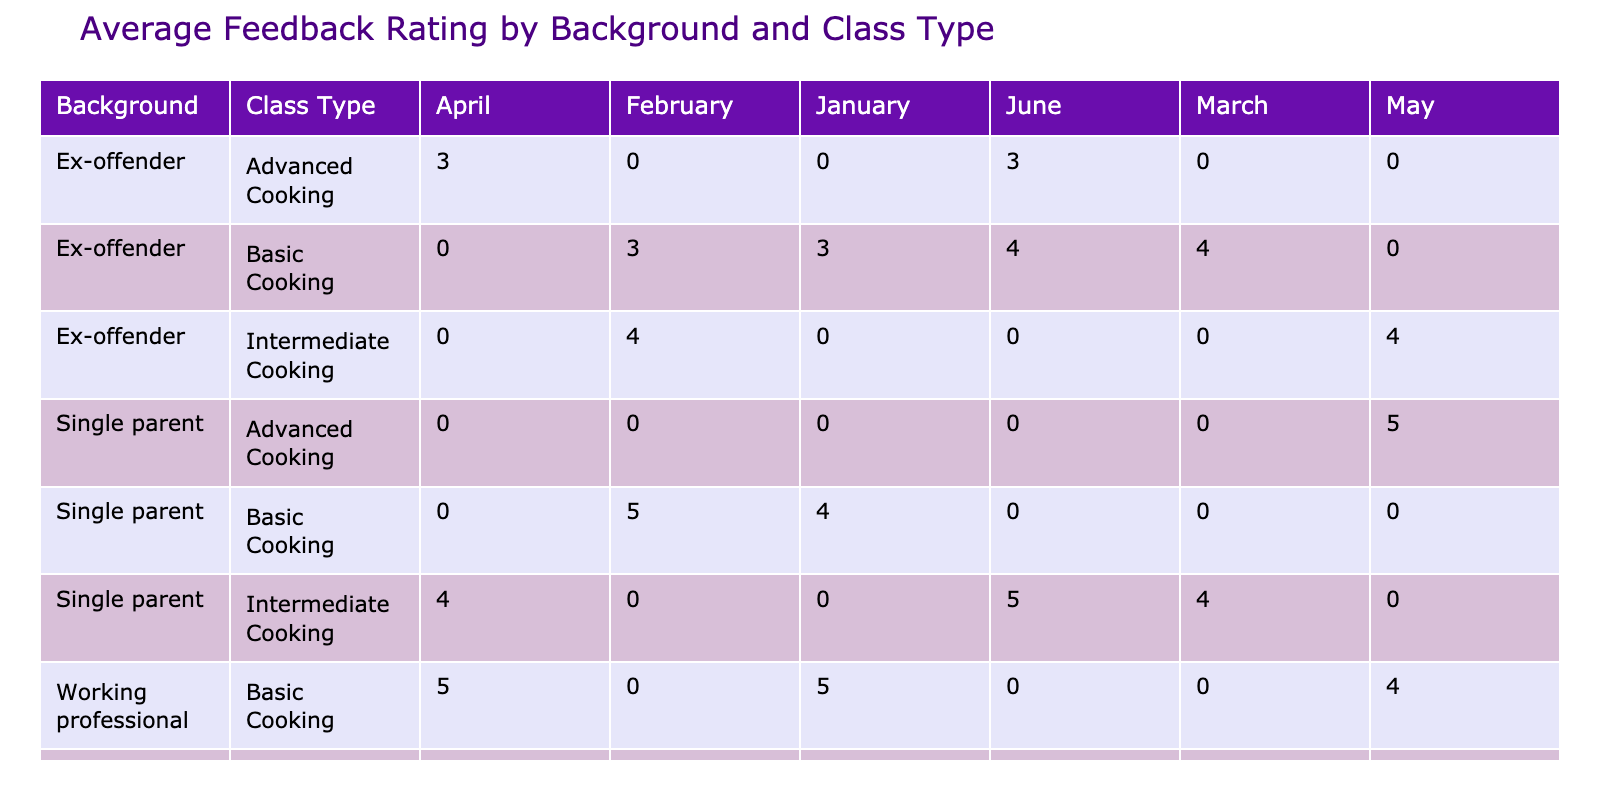What is the average feedback rating for single parents in Basic Cooking classes? To find this, we look at the Basic Cooking class under the Background of Single parents. There's data for January (4), February (5), March (not applicable), April (not applicable), May (not applicable), and June (not applicable). The average is calculated as (4 + 5) / 2 = 4.5.
Answer: 4.5 Which Class Type received the highest average feedback rating in June? Looking at June, we see the feedback ratings: Ex-offender in Advanced Cooking has 3, Single parent in Intermediate Cooking has 5, and Ex-offender in Basic Cooking has 4. The highest here is 5 from the Single parent in Intermediate Cooking.
Answer: 5 Did the students from the Ex-offender background recommend their classes in February? In February, we check the Ex-offender background. There were two attendees, Tom Wilson (No) and John Smith (Yes). So, not all Ex-offenders recommended their classes.
Answer: No What was the total average feedback rating for Intermediate Cooking classes across all months? We first identify all Intermediate Cooking entries: February (4), March (4), April (4), and June (5). Adding these gives us (4 + 4 + 4 + 5) = 17. There are 4 entries, so the average is 17 / 4 = 4.25.
Answer: 4.25 Is it true that all students from the Ex-offender background attended at least one Intermediate Cooking class? Looking through the data, we see Ex-offender attendees in Basic Cooking (Mike Thompson, Tom Wilson) and one in Intermediate (John Smith, James Wilson). Therefore, it is not true that all Ex-offenders attended Intermediate Cooking.
Answer: No Which dish prepared in April received the lowest feedback rating? In April, we check each dish's feedback ratings: Beef Wellington (3), Lasagna (4), and Caesar Salad (5). The Beef Wellington has the lowest rating at 3.
Answer: Beef Wellington How many different dishes did single parents prepare across all months? We check each dish prepared by single parents: Spaghetti Bolognese, Grilled Salmon, Chicken Curry, Lasagna, Coq au Vin, and Mushroom Risotto. This gives us a total of 6 distinct dishes.
Answer: 6 What is the average feedback rating for Ex-offenders across all months? We find the feedback ratings for each month: January (3), February (4), March (4), April (3), May (4), June (3). Summing these gives us a total of 21 for 6 entries, resulting in an average of 21 / 6 = 3.5.
Answer: 3.5 Which month had the highest feedback rating for Advanced Cooking classes? From the data, we check Advanced Cooking classes: April has 3, and May has 5. The highest rating is May with a feedback rating of 5.
Answer: May 